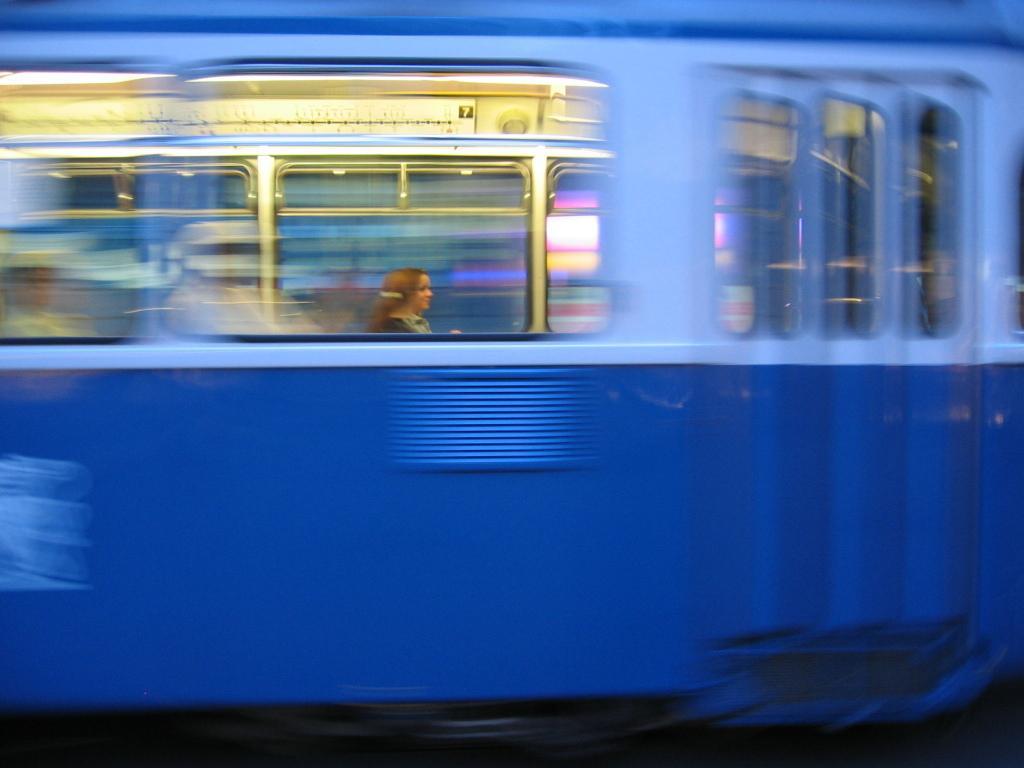Could you give a brief overview of what you see in this image? In this image I can see the vehicle which is in blue color. There are windows to the vehicle. Inside the vehicle I can see the person. 